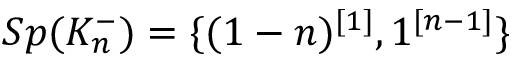<formula> <loc_0><loc_0><loc_500><loc_500>S p ( K _ { n } ^ { - } ) = \{ ( 1 - n ) ^ { [ 1 ] } , 1 ^ { [ n - 1 ] } \}</formula> 